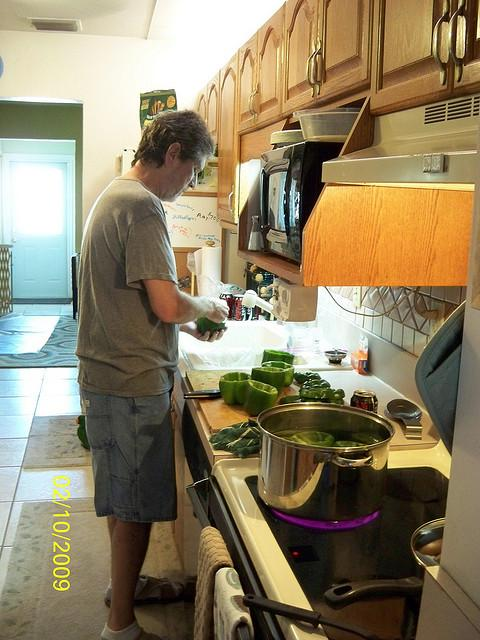What is the person cutting? Please explain your reasoning. green peppers. A man is standing there in the kitchen as he is preparing green peppers in his hand. there are other peppers on the kitchen counter with a pot cooking. 